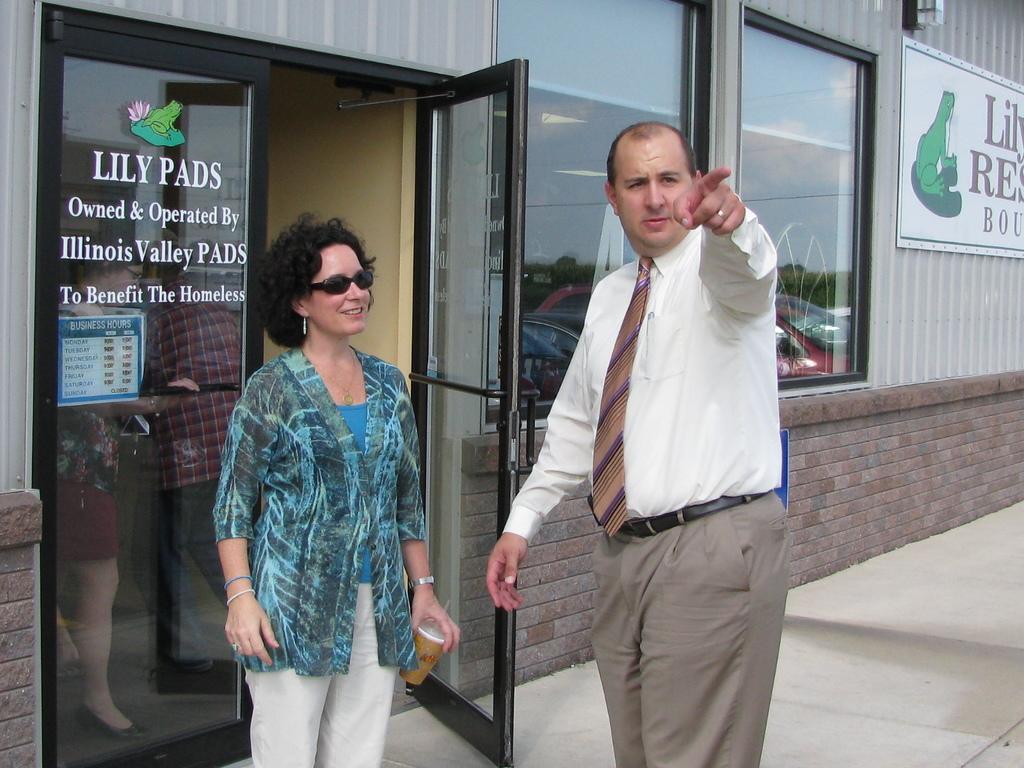Can you describe this image briefly? In this picture I can observe a man and woman in the middle of the picture. In the background I can observe building. 